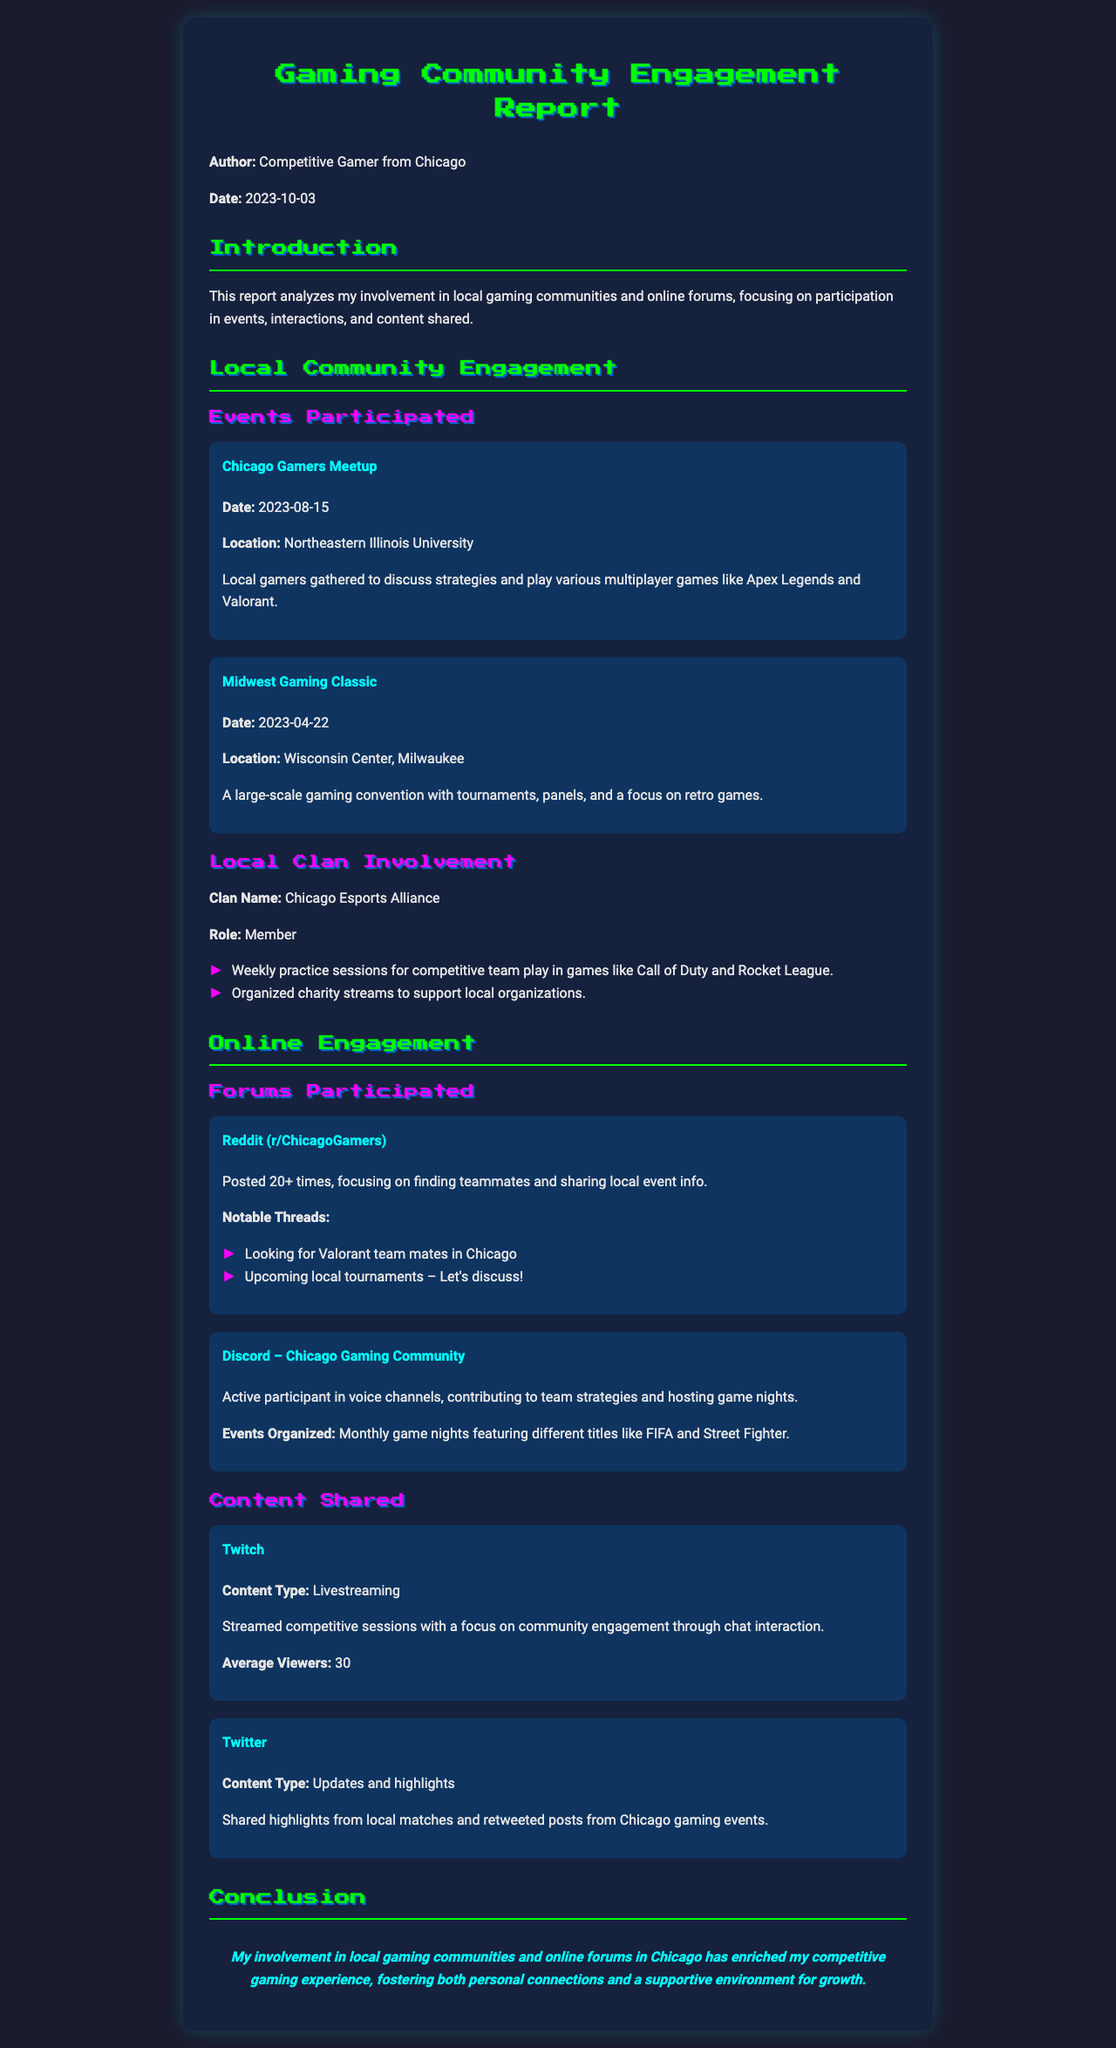What event took place on August 15, 2023? The document states that the Chicago Gamers Meetup took place on this date.
Answer: Chicago Gamers Meetup What is the name of the clan mentioned in the report? The report mentions the Chicago Esports Alliance as the clan involved.
Answer: Chicago Esports Alliance How many times did the author post on Reddit (r/ChicagoGamers)? The document specifies that the author posted 20+ times on this forum.
Answer: 20+ What type of content does the author share on Twitch? The report shows that the author streams competitive sessions focused on community engagement.
Answer: Livestreaming Which gaming events does the Discord community organize monthly? The document mentions different titles like FIFA and Street Fighter for the monthly game nights.
Answer: FIFA and Street Fighter What location hosted the Midwest Gaming Classic? According to the report, it was held at the Wisconsin Center in Milwaukee.
Answer: Wisconsin Center, Milwaukee What was a notable thread discussed on the Reddit forum? The document lists "Looking for Valorant team mates in Chicago" as one of the notable threads.
Answer: Looking for Valorant team mates in Chicago What is the average number of viewers during the author's Twitch streams? The document indicates that the author had an average of 30 viewers.
Answer: 30 What role does the author hold in the Chicago Esports Alliance? The report states that the author is a member of the clan.
Answer: Member 